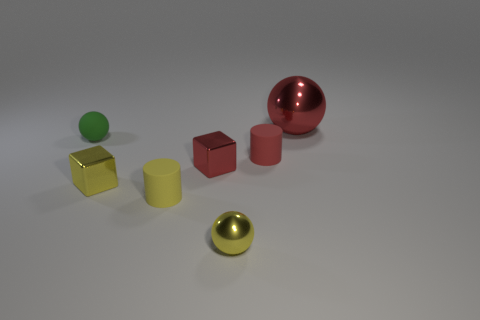Are there any other things that are the same size as the red sphere?
Provide a succinct answer. No. Do the red ball and the tiny ball on the right side of the yellow cylinder have the same material?
Offer a very short reply. Yes. What number of other things are there of the same shape as the small red rubber thing?
Offer a terse response. 1. What number of objects are either red metal things that are in front of the large red object or tiny rubber things in front of the green rubber sphere?
Your answer should be very brief. 3. How many other objects are there of the same color as the large thing?
Keep it short and to the point. 2. Are there fewer big red objects that are on the right side of the big shiny thing than tiny yellow objects right of the yellow rubber cylinder?
Your response must be concise. Yes. What number of small purple cylinders are there?
Provide a short and direct response. 0. What material is the small green thing that is the same shape as the large thing?
Make the answer very short. Rubber. Is the number of small red objects that are behind the small matte ball less than the number of tiny metallic spheres?
Give a very brief answer. Yes. There is a yellow object that is on the right side of the tiny red block; does it have the same shape as the big red object?
Your answer should be compact. Yes. 